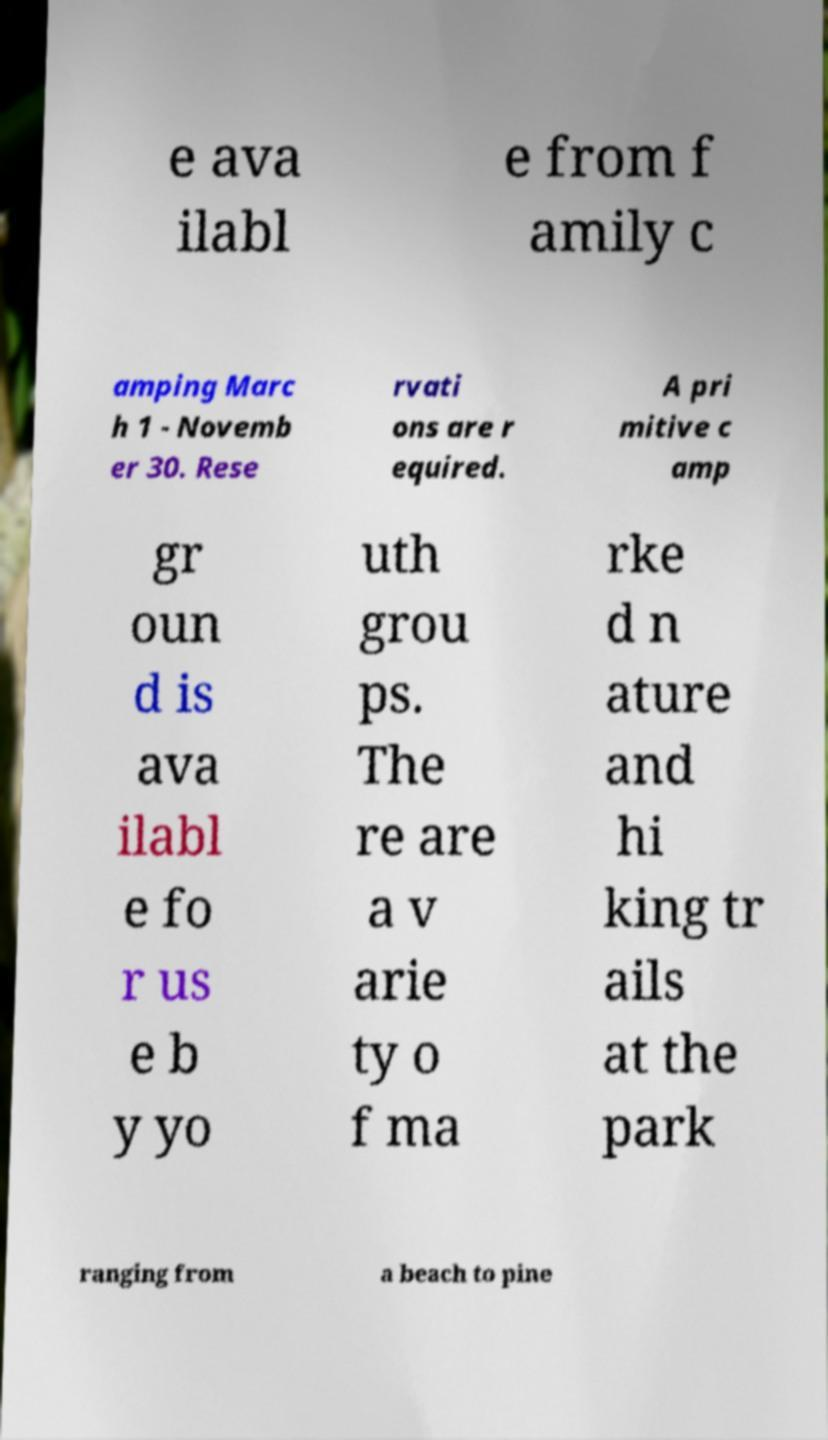Can you read and provide the text displayed in the image?This photo seems to have some interesting text. Can you extract and type it out for me? e ava ilabl e from f amily c amping Marc h 1 - Novemb er 30. Rese rvati ons are r equired. A pri mitive c amp gr oun d is ava ilabl e fo r us e b y yo uth grou ps. The re are a v arie ty o f ma rke d n ature and hi king tr ails at the park ranging from a beach to pine 